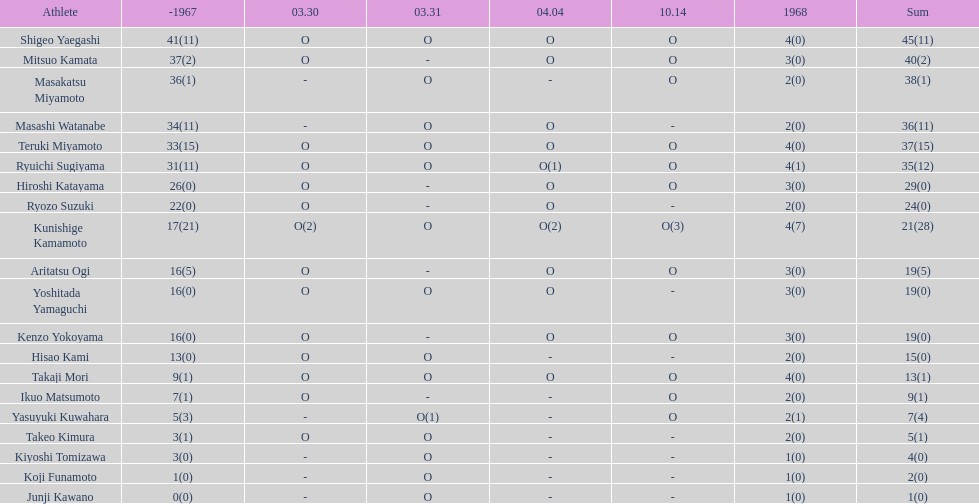How many total did mitsuo kamata have? 40(2). 